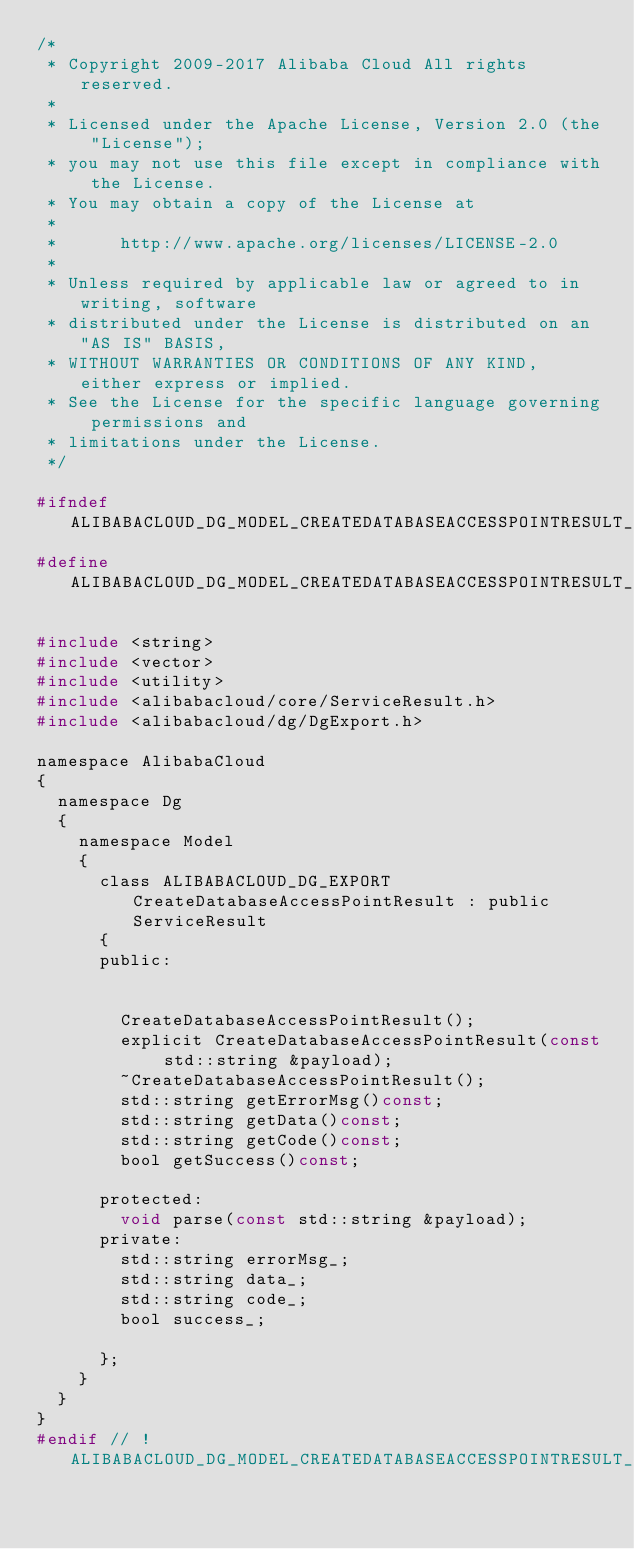Convert code to text. <code><loc_0><loc_0><loc_500><loc_500><_C_>/*
 * Copyright 2009-2017 Alibaba Cloud All rights reserved.
 * 
 * Licensed under the Apache License, Version 2.0 (the "License");
 * you may not use this file except in compliance with the License.
 * You may obtain a copy of the License at
 * 
 *      http://www.apache.org/licenses/LICENSE-2.0
 * 
 * Unless required by applicable law or agreed to in writing, software
 * distributed under the License is distributed on an "AS IS" BASIS,
 * WITHOUT WARRANTIES OR CONDITIONS OF ANY KIND, either express or implied.
 * See the License for the specific language governing permissions and
 * limitations under the License.
 */

#ifndef ALIBABACLOUD_DG_MODEL_CREATEDATABASEACCESSPOINTRESULT_H_
#define ALIBABACLOUD_DG_MODEL_CREATEDATABASEACCESSPOINTRESULT_H_

#include <string>
#include <vector>
#include <utility>
#include <alibabacloud/core/ServiceResult.h>
#include <alibabacloud/dg/DgExport.h>

namespace AlibabaCloud
{
	namespace Dg
	{
		namespace Model
		{
			class ALIBABACLOUD_DG_EXPORT CreateDatabaseAccessPointResult : public ServiceResult
			{
			public:


				CreateDatabaseAccessPointResult();
				explicit CreateDatabaseAccessPointResult(const std::string &payload);
				~CreateDatabaseAccessPointResult();
				std::string getErrorMsg()const;
				std::string getData()const;
				std::string getCode()const;
				bool getSuccess()const;

			protected:
				void parse(const std::string &payload);
			private:
				std::string errorMsg_;
				std::string data_;
				std::string code_;
				bool success_;

			};
		}
	}
}
#endif // !ALIBABACLOUD_DG_MODEL_CREATEDATABASEACCESSPOINTRESULT_H_</code> 